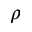Convert formula to latex. <formula><loc_0><loc_0><loc_500><loc_500>\rho</formula> 